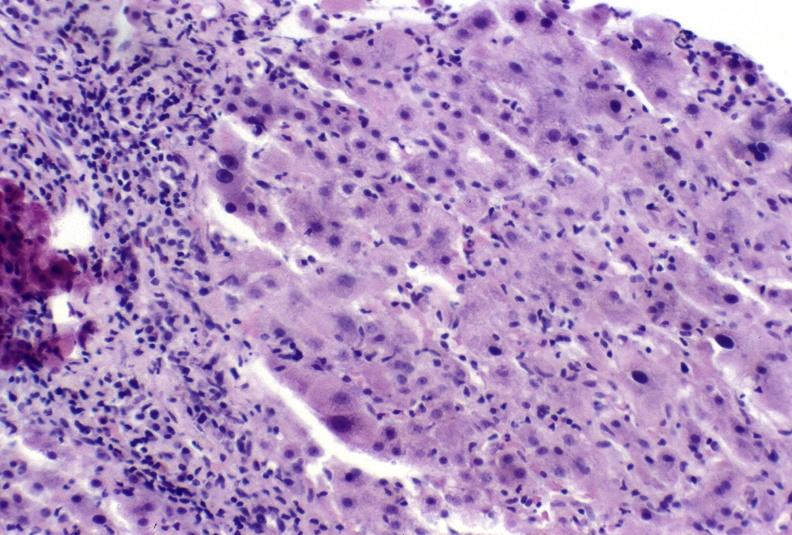does this image show autoimmune hepatitis?
Answer the question using a single word or phrase. Yes 